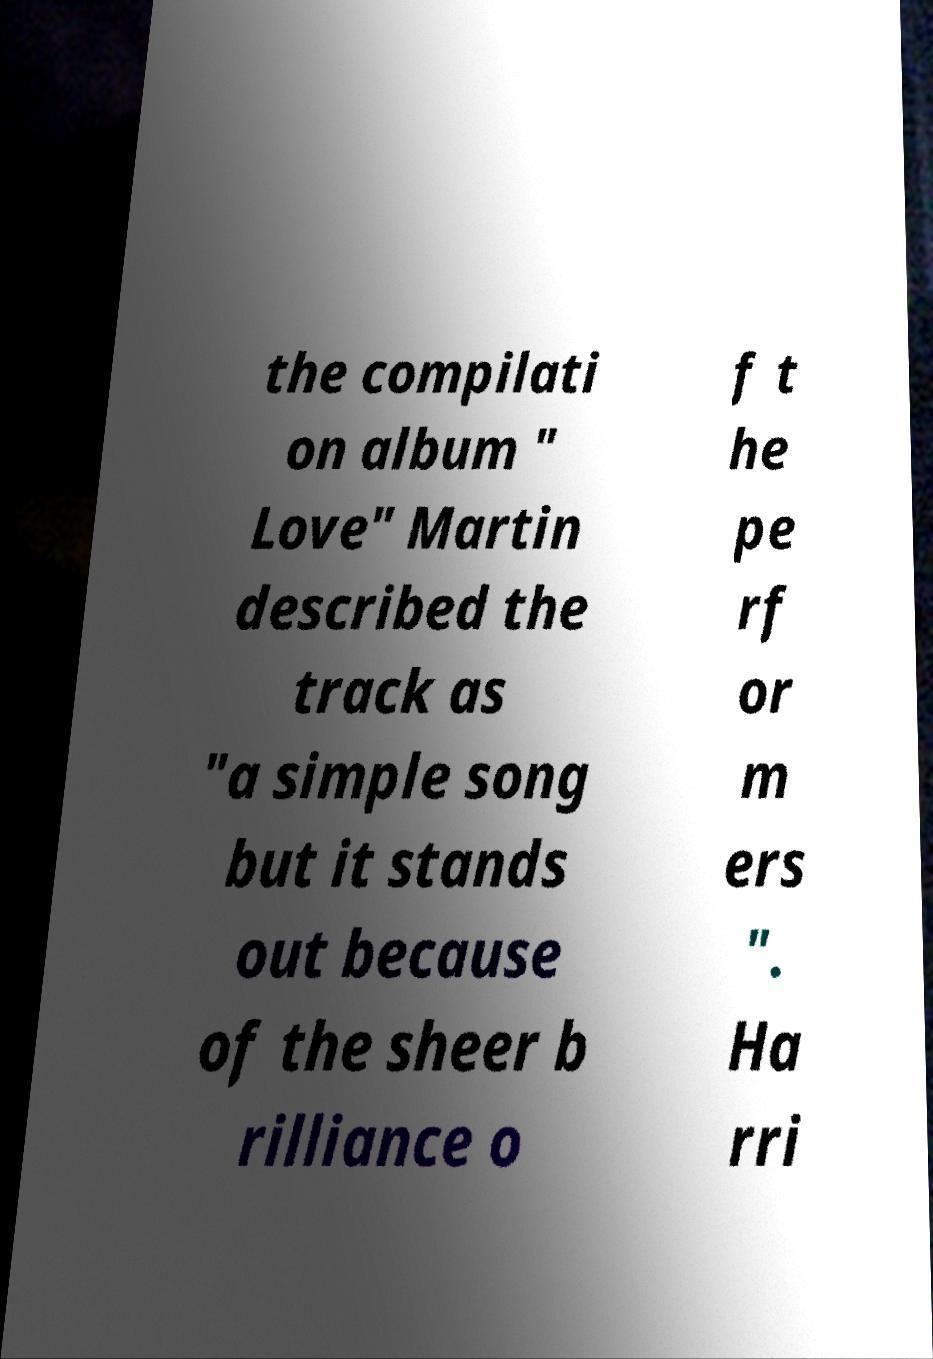What messages or text are displayed in this image? I need them in a readable, typed format. the compilati on album " Love" Martin described the track as "a simple song but it stands out because of the sheer b rilliance o f t he pe rf or m ers ". Ha rri 